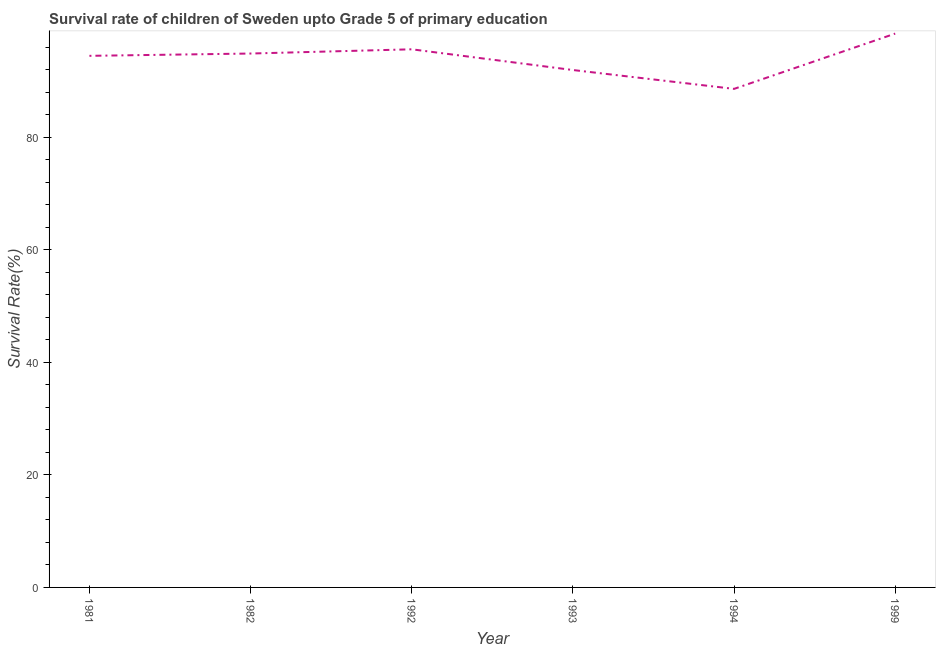What is the survival rate in 1981?
Your answer should be very brief. 94.48. Across all years, what is the maximum survival rate?
Provide a short and direct response. 98.43. Across all years, what is the minimum survival rate?
Make the answer very short. 88.61. What is the sum of the survival rate?
Give a very brief answer. 564.01. What is the difference between the survival rate in 1981 and 1994?
Offer a terse response. 5.87. What is the average survival rate per year?
Your response must be concise. 94. What is the median survival rate?
Provide a succinct answer. 94.68. In how many years, is the survival rate greater than 24 %?
Give a very brief answer. 6. Do a majority of the years between 1999 and 1981 (inclusive) have survival rate greater than 48 %?
Your response must be concise. Yes. What is the ratio of the survival rate in 1982 to that in 1999?
Make the answer very short. 0.96. Is the survival rate in 1982 less than that in 1992?
Provide a short and direct response. Yes. Is the difference between the survival rate in 1981 and 1993 greater than the difference between any two years?
Make the answer very short. No. What is the difference between the highest and the second highest survival rate?
Your answer should be compact. 2.79. What is the difference between the highest and the lowest survival rate?
Offer a very short reply. 9.83. In how many years, is the survival rate greater than the average survival rate taken over all years?
Offer a terse response. 4. Does the survival rate monotonically increase over the years?
Give a very brief answer. No. How many lines are there?
Offer a very short reply. 1. How many years are there in the graph?
Offer a very short reply. 6. Does the graph contain any zero values?
Provide a short and direct response. No. What is the title of the graph?
Provide a succinct answer. Survival rate of children of Sweden upto Grade 5 of primary education. What is the label or title of the Y-axis?
Keep it short and to the point. Survival Rate(%). What is the Survival Rate(%) in 1981?
Make the answer very short. 94.48. What is the Survival Rate(%) of 1982?
Offer a terse response. 94.89. What is the Survival Rate(%) of 1992?
Make the answer very short. 95.64. What is the Survival Rate(%) of 1993?
Your response must be concise. 91.96. What is the Survival Rate(%) in 1994?
Ensure brevity in your answer.  88.61. What is the Survival Rate(%) in 1999?
Your answer should be very brief. 98.43. What is the difference between the Survival Rate(%) in 1981 and 1982?
Ensure brevity in your answer.  -0.41. What is the difference between the Survival Rate(%) in 1981 and 1992?
Make the answer very short. -1.16. What is the difference between the Survival Rate(%) in 1981 and 1993?
Keep it short and to the point. 2.52. What is the difference between the Survival Rate(%) in 1981 and 1994?
Provide a short and direct response. 5.87. What is the difference between the Survival Rate(%) in 1981 and 1999?
Make the answer very short. -3.95. What is the difference between the Survival Rate(%) in 1982 and 1992?
Ensure brevity in your answer.  -0.75. What is the difference between the Survival Rate(%) in 1982 and 1993?
Give a very brief answer. 2.93. What is the difference between the Survival Rate(%) in 1982 and 1994?
Your response must be concise. 6.28. What is the difference between the Survival Rate(%) in 1982 and 1999?
Make the answer very short. -3.54. What is the difference between the Survival Rate(%) in 1992 and 1993?
Your response must be concise. 3.68. What is the difference between the Survival Rate(%) in 1992 and 1994?
Offer a terse response. 7.03. What is the difference between the Survival Rate(%) in 1992 and 1999?
Give a very brief answer. -2.79. What is the difference between the Survival Rate(%) in 1993 and 1994?
Your response must be concise. 3.35. What is the difference between the Survival Rate(%) in 1993 and 1999?
Keep it short and to the point. -6.48. What is the difference between the Survival Rate(%) in 1994 and 1999?
Your response must be concise. -9.83. What is the ratio of the Survival Rate(%) in 1981 to that in 1994?
Offer a terse response. 1.07. What is the ratio of the Survival Rate(%) in 1981 to that in 1999?
Keep it short and to the point. 0.96. What is the ratio of the Survival Rate(%) in 1982 to that in 1993?
Give a very brief answer. 1.03. What is the ratio of the Survival Rate(%) in 1982 to that in 1994?
Make the answer very short. 1.07. What is the ratio of the Survival Rate(%) in 1982 to that in 1999?
Make the answer very short. 0.96. What is the ratio of the Survival Rate(%) in 1992 to that in 1993?
Your response must be concise. 1.04. What is the ratio of the Survival Rate(%) in 1992 to that in 1994?
Keep it short and to the point. 1.08. What is the ratio of the Survival Rate(%) in 1992 to that in 1999?
Give a very brief answer. 0.97. What is the ratio of the Survival Rate(%) in 1993 to that in 1994?
Keep it short and to the point. 1.04. What is the ratio of the Survival Rate(%) in 1993 to that in 1999?
Your answer should be very brief. 0.93. What is the ratio of the Survival Rate(%) in 1994 to that in 1999?
Offer a very short reply. 0.9. 